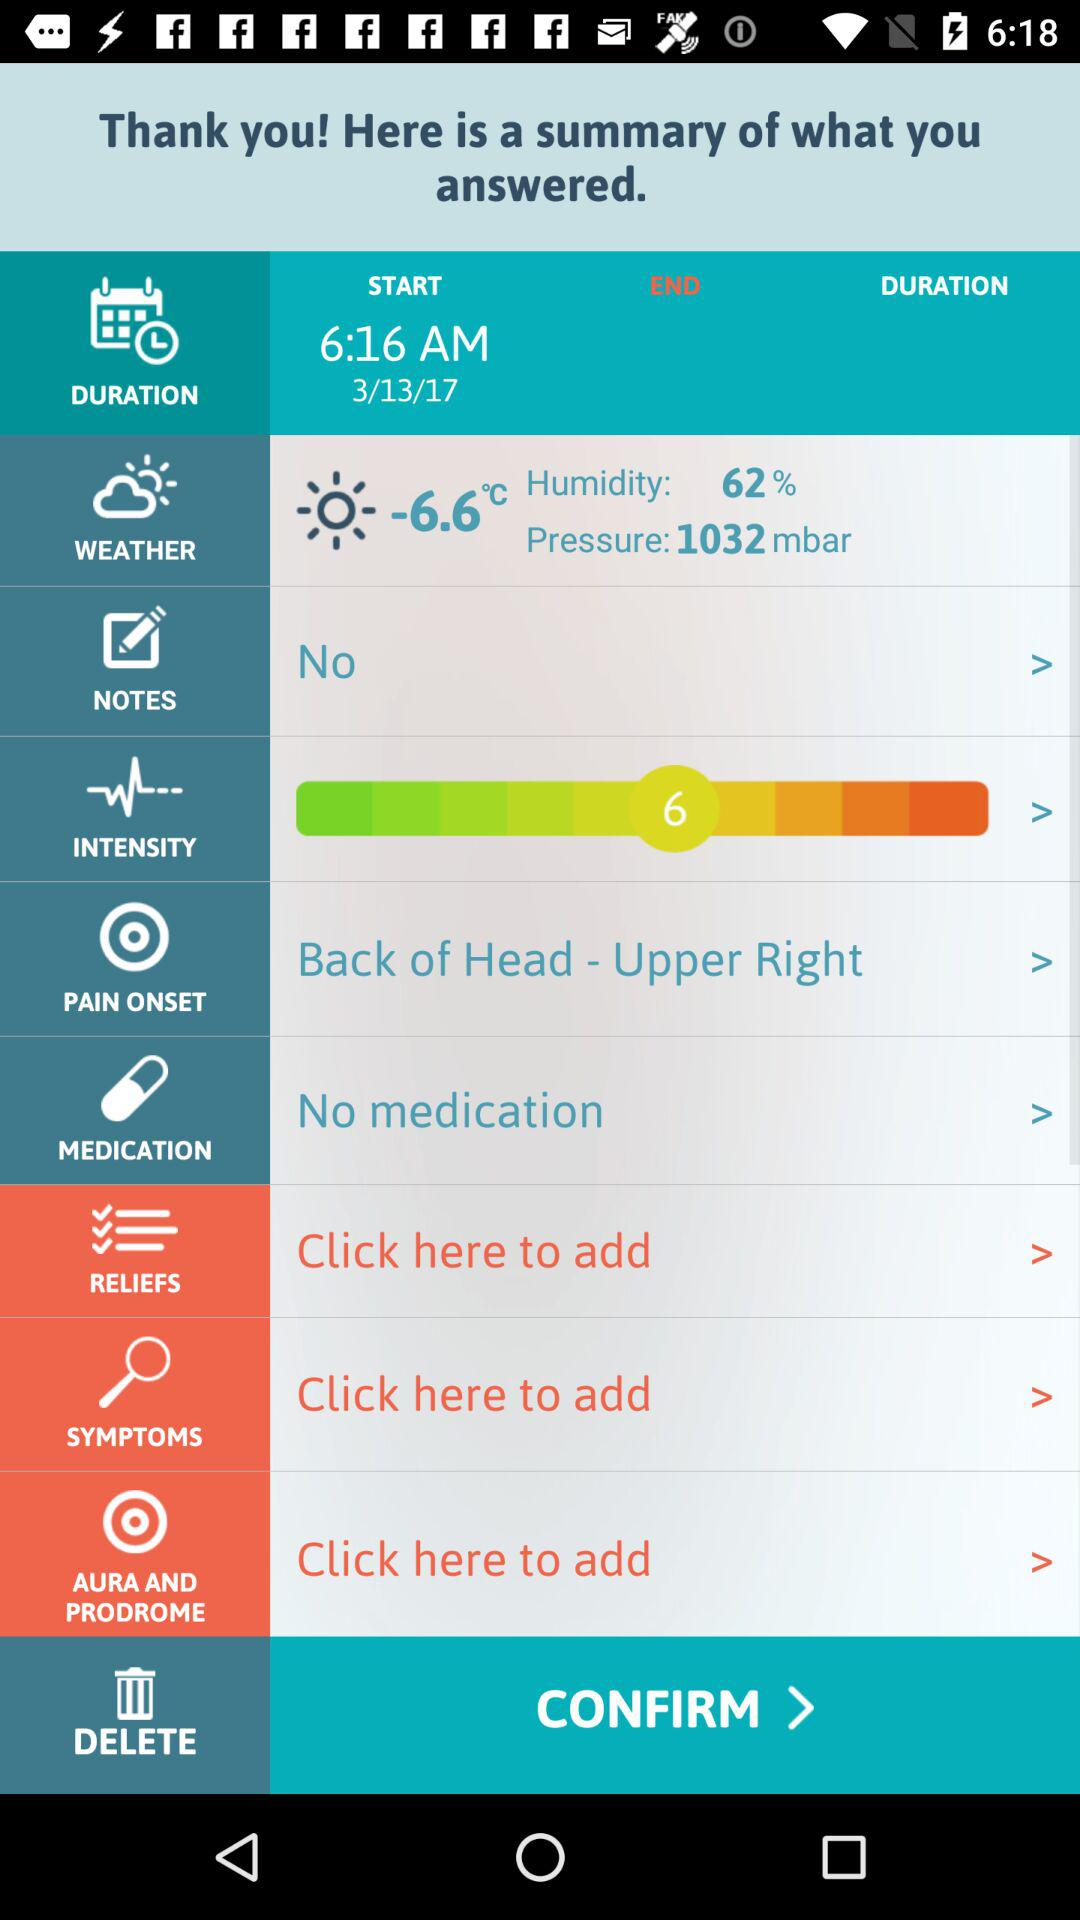What is the start time? The start time is 6:16 AM. 